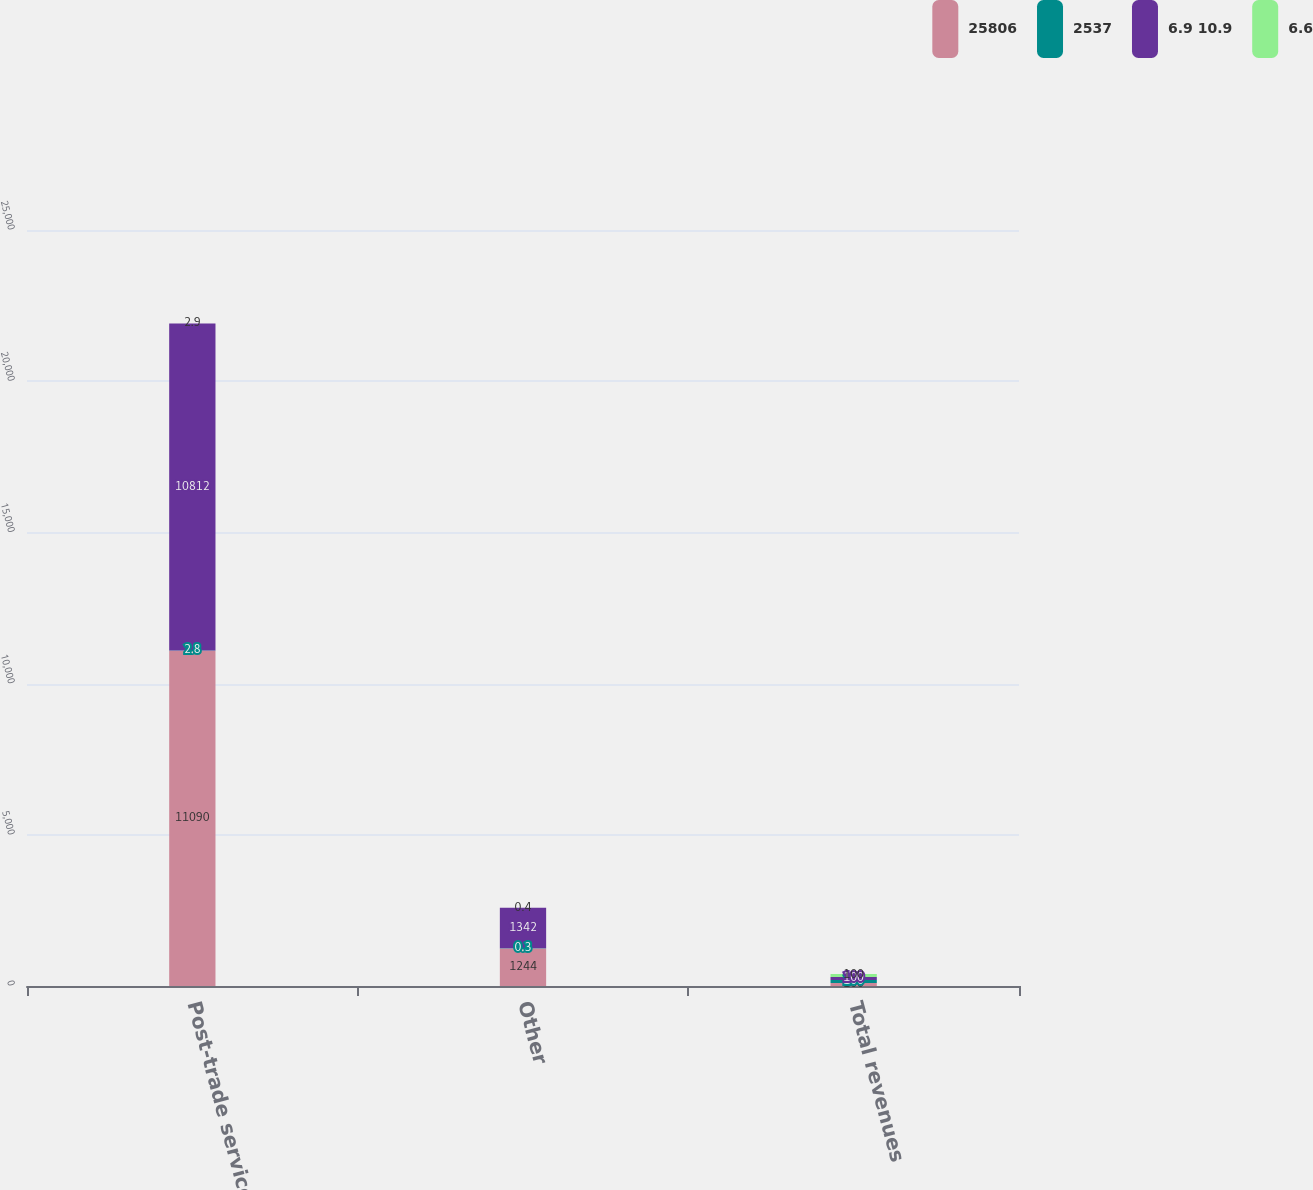<chart> <loc_0><loc_0><loc_500><loc_500><stacked_bar_chart><ecel><fcel>Post-trade services<fcel>Other<fcel>Total revenues<nl><fcel>25806<fcel>11090<fcel>1244<fcel>100<nl><fcel>2537<fcel>2.8<fcel>0.3<fcel>100<nl><fcel>6.9 10.9<fcel>10812<fcel>1342<fcel>100<nl><fcel>6.6<fcel>2.9<fcel>0.4<fcel>100<nl></chart> 